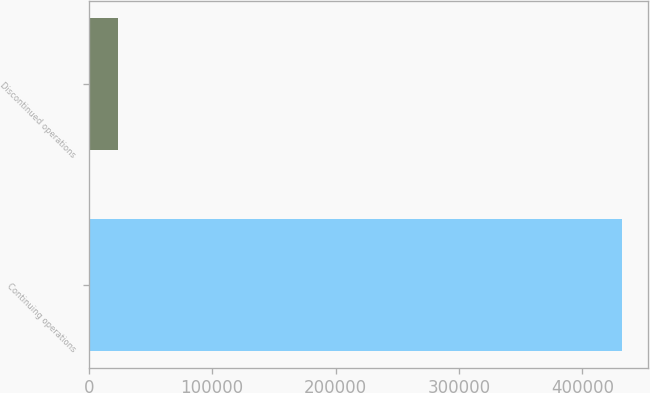<chart> <loc_0><loc_0><loc_500><loc_500><bar_chart><fcel>Continuing operations<fcel>Discontinued operations<nl><fcel>431761<fcel>24052<nl></chart> 